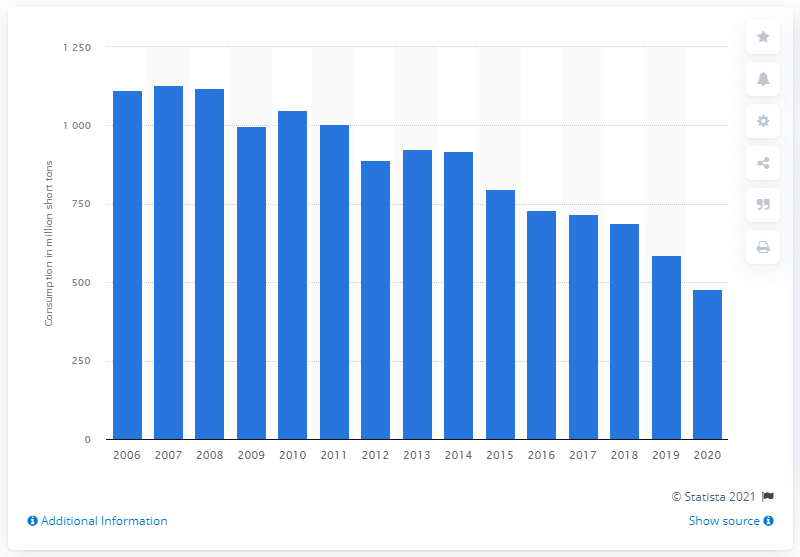Outline some significant characteristics in this image. In 2020, the U.S. consumed 477.3 million short tons of coal. 